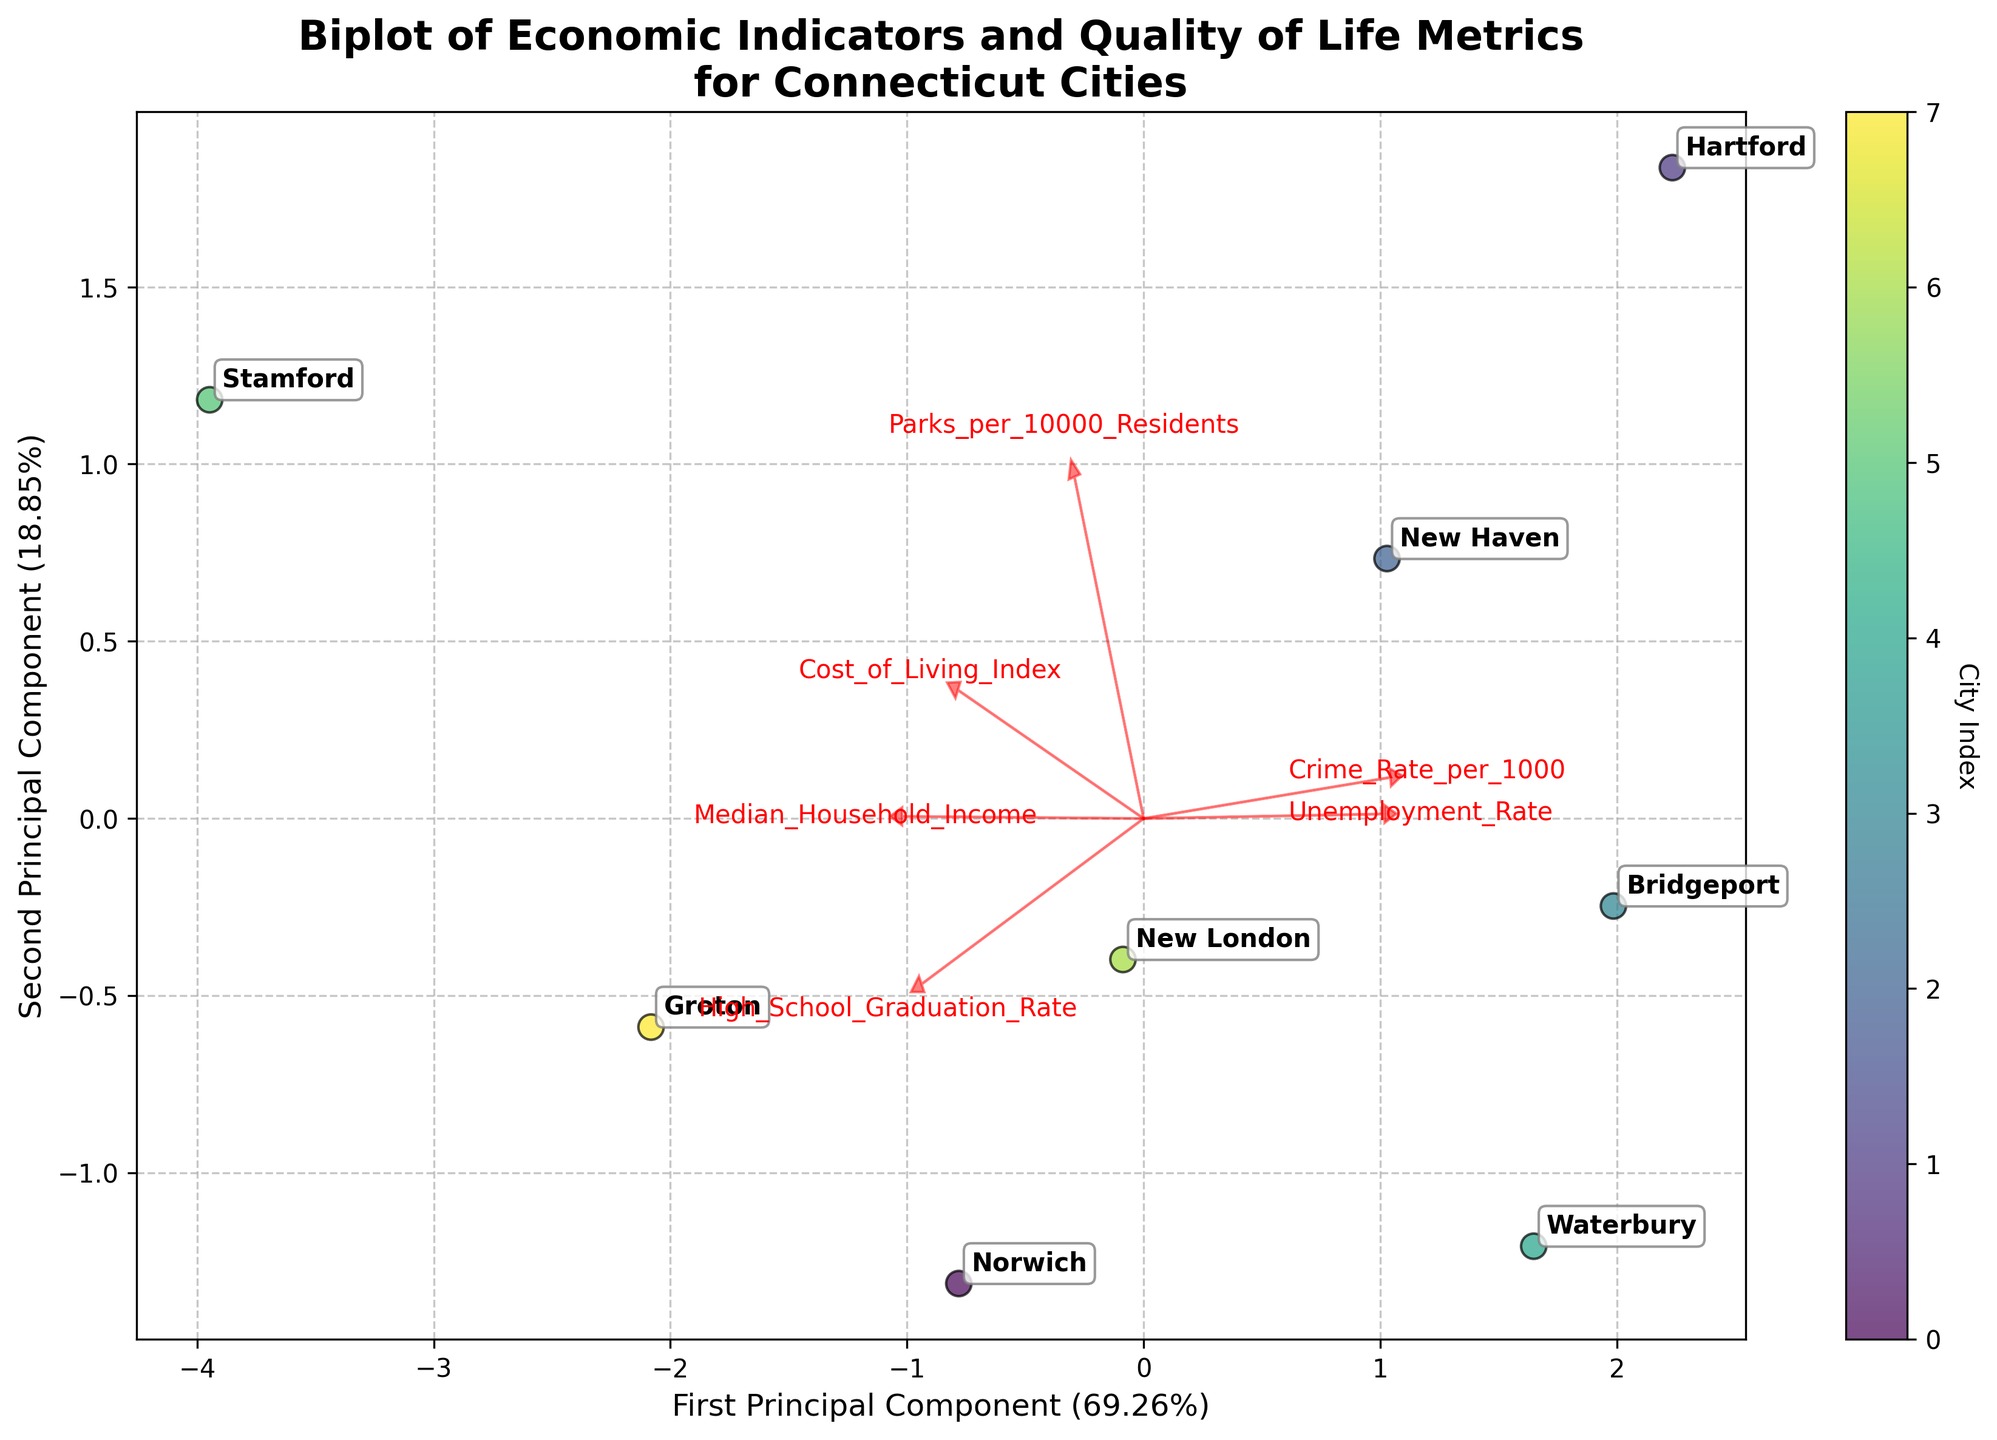What does the title of the plot say? The title of the plot is displayed at the top of the figure, which typically summarizes what the plot represents. In this case, it clearly states what the plot is about.
Answer: Biplot of Economic Indicators and Quality of Life Metrics for Connecticut Cities How many cities are represented in the plot? To determine the number of cities, count the number of data points or city labels present in the plot.
Answer: 8 Which city has the highest median household income? To find this, look for the city label that is farthest along the direction of the eigenvector corresponding to "Median_Household_Income".
Answer: Stamford Which city has the highest unemployment rate? Identify the city label that is farthest along the direction of the eigenvector corresponding to "Unemployment_Rate".
Answer: Bridgeport What is the first principal component axis capturing? Look at the direction and length of the vectors in relation to the first principal component axis. The axis captures the maximum variance in the data, represented by the eigenvectors.
Answer: Income, unemployment, and cost of living How does Norwich compare to New Haven in terms of high school graduation rate? Compare the relative positions of Norwich and New Haven along the direction of the eigenvector corresponding to "High_School_Graduation_Rate".
Answer: Norwich has a higher rate Which feature has the smallest impact on the second principal component? Identify the eigenvector that is shortest in the direction of the second principal component.
Answer: Median_Household_Income Are crime rates and parks per 10000 residents positively or negatively correlated in these cities? Look at the directions of the eigenvectors for "Crime_Rate_per_1000" and "Parks_per_10000_Residents". If they point in the same general direction, they are positively correlated; if they point in opposite directions, they are negatively correlated.
Answer: Positively correlated Which two cities are most similar based on the first and second principal components? Look at which city labels are closest to each other on the plot.
Answer: New London and Groton 